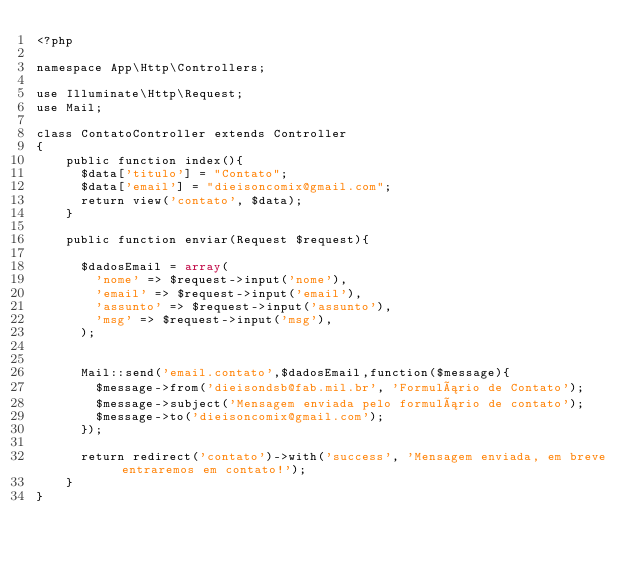Convert code to text. <code><loc_0><loc_0><loc_500><loc_500><_PHP_><?php

namespace App\Http\Controllers;

use Illuminate\Http\Request;
use Mail;

class ContatoController extends Controller
{
    public function index(){
    	$data['titulo'] = "Contato";
    	$data['email'] = "dieisoncomix@gmail.com";
    	return view('contato', $data);
    }

    public function enviar(Request $request){
    	
    	$dadosEmail = array(
    		'nome' => $request->input('nome'),
    		'email' => $request->input('email'),
    		'assunto' => $request->input('assunto'),
    		'msg' => $request->input('msg'),
    	);


    	Mail::send('email.contato',$dadosEmail,function($message){
    		$message->from('dieisondsb@fab.mil.br', 'Formulário de Contato');
    		$message->subject('Mensagem enviada pelo formulário de contato');
    		$message->to('dieisoncomix@gmail.com');
    	});

    	return redirect('contato')->with('success', 'Mensagem enviada, em breve entraremos em contato!');
    }
}
</code> 